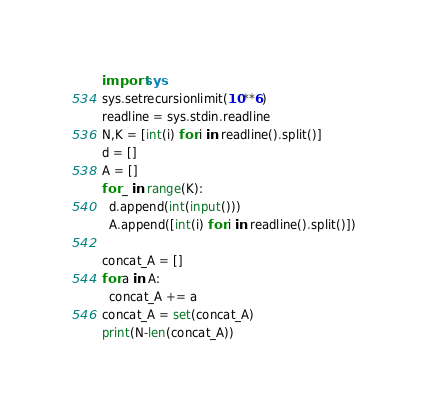<code> <loc_0><loc_0><loc_500><loc_500><_Python_>import sys
sys.setrecursionlimit(10**6)
readline = sys.stdin.readline
N,K = [int(i) for i in readline().split()]
d = []
A = []
for _ in range(K):
  d.append(int(input()))
  A.append([int(i) for i in readline().split()])

concat_A = []
for a in A:
  concat_A += a
concat_A = set(concat_A)
print(N-len(concat_A))</code> 